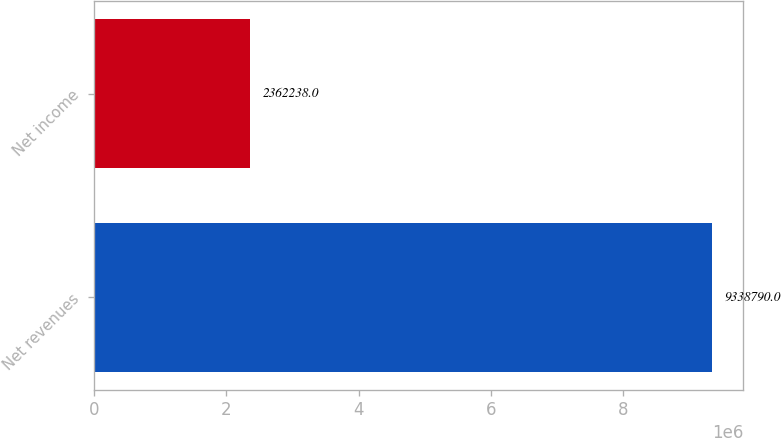Convert chart to OTSL. <chart><loc_0><loc_0><loc_500><loc_500><bar_chart><fcel>Net revenues<fcel>Net income<nl><fcel>9.33879e+06<fcel>2.36224e+06<nl></chart> 